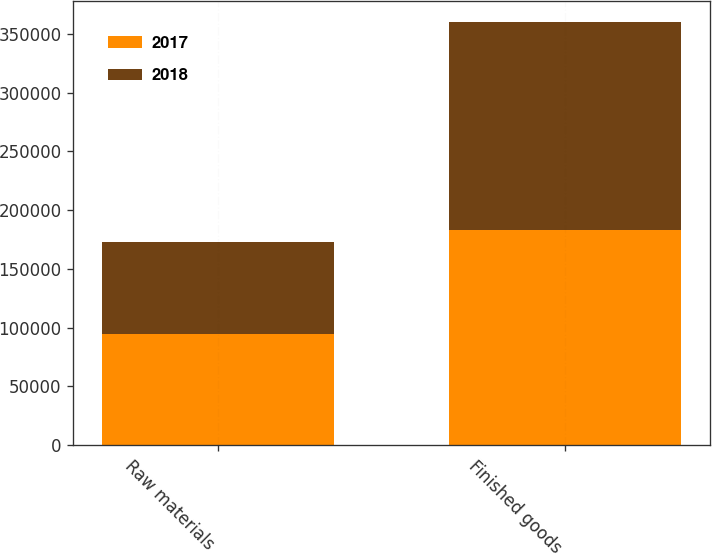Convert chart. <chart><loc_0><loc_0><loc_500><loc_500><stacked_bar_chart><ecel><fcel>Raw materials<fcel>Finished goods<nl><fcel>2017<fcel>94421<fcel>183284<nl><fcel>2018<fcel>78834<fcel>176911<nl></chart> 